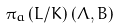Convert formula to latex. <formula><loc_0><loc_0><loc_500><loc_500>\pi _ { a } \left ( L / K \right ) \left ( \Lambda , B \right )</formula> 